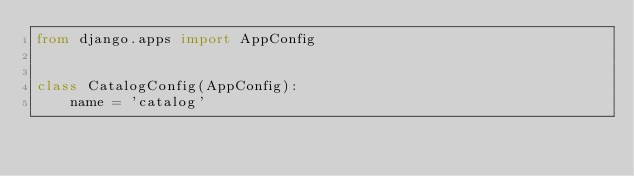Convert code to text. <code><loc_0><loc_0><loc_500><loc_500><_Python_>from django.apps import AppConfig


class CatalogConfig(AppConfig):
    name = 'catalog'
</code> 